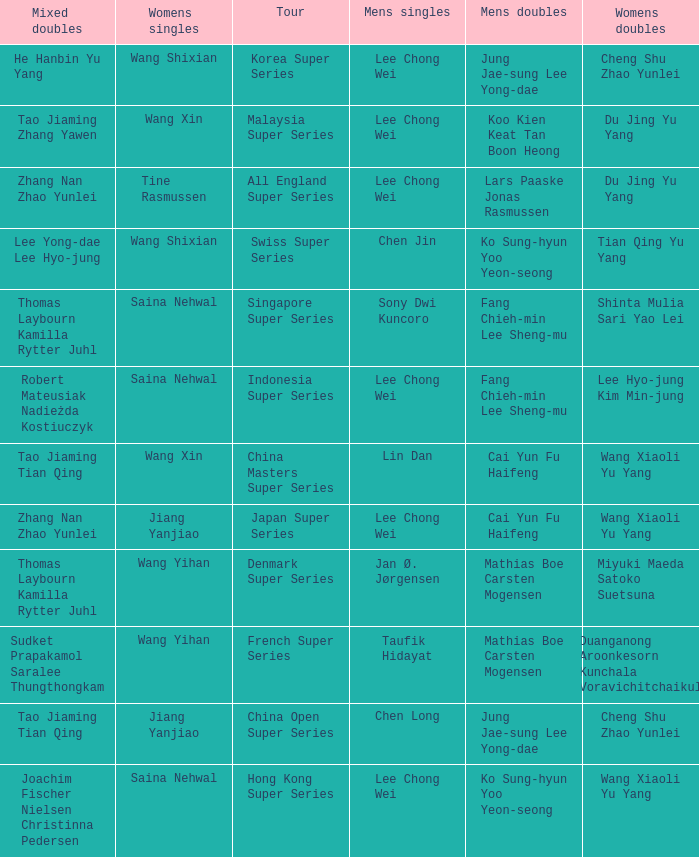Who is the women's doubles when the mixed doubles are sudket prapakamol saralee thungthongkam? Duanganong Aroonkesorn Kunchala Voravichitchaikul. 